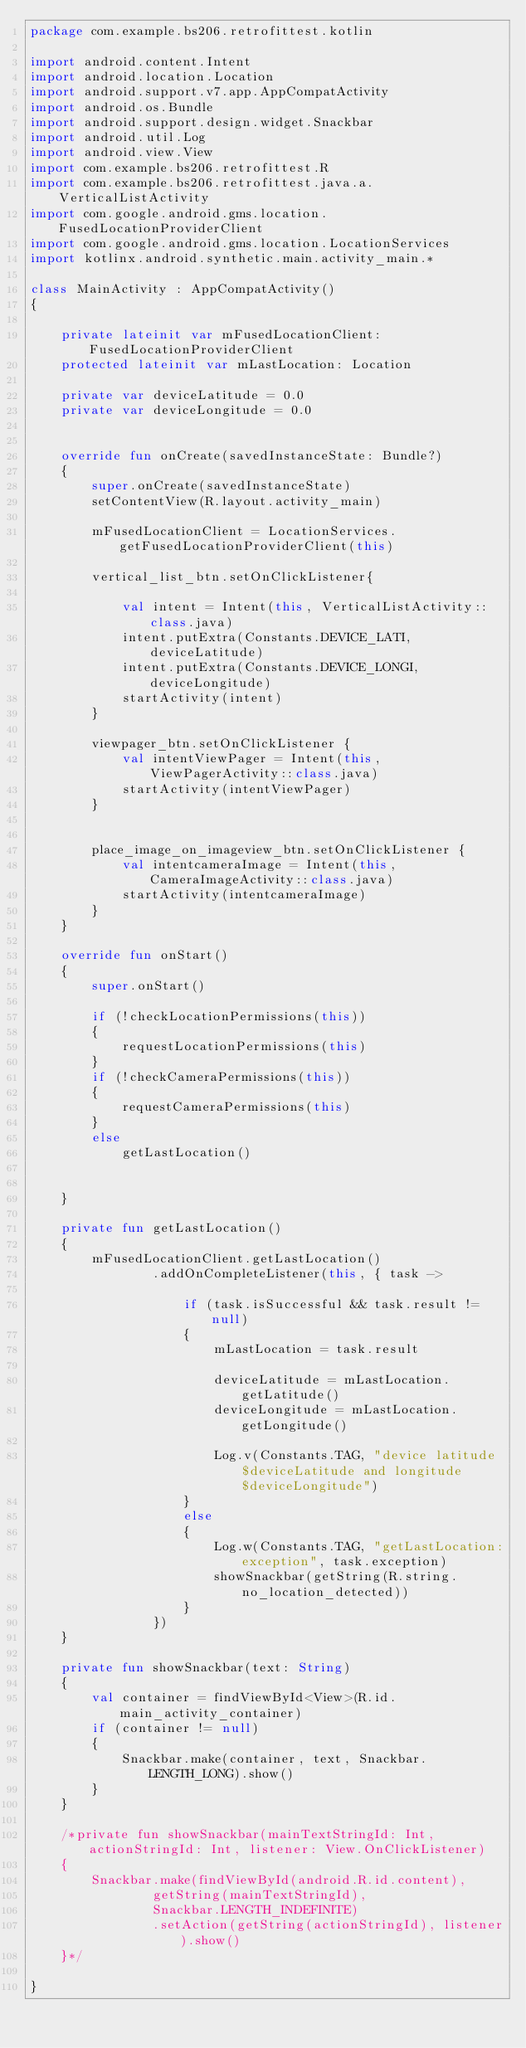Convert code to text. <code><loc_0><loc_0><loc_500><loc_500><_Kotlin_>package com.example.bs206.retrofittest.kotlin

import android.content.Intent
import android.location.Location
import android.support.v7.app.AppCompatActivity
import android.os.Bundle
import android.support.design.widget.Snackbar
import android.util.Log
import android.view.View
import com.example.bs206.retrofittest.R
import com.example.bs206.retrofittest.java.a.VerticalListActivity
import com.google.android.gms.location.FusedLocationProviderClient
import com.google.android.gms.location.LocationServices
import kotlinx.android.synthetic.main.activity_main.*

class MainActivity : AppCompatActivity()
{

    private lateinit var mFusedLocationClient: FusedLocationProviderClient
    protected lateinit var mLastLocation: Location

    private var deviceLatitude = 0.0
    private var deviceLongitude = 0.0


    override fun onCreate(savedInstanceState: Bundle?)
    {
        super.onCreate(savedInstanceState)
        setContentView(R.layout.activity_main)

        mFusedLocationClient = LocationServices.getFusedLocationProviderClient(this)

        vertical_list_btn.setOnClickListener{

            val intent = Intent(this, VerticalListActivity::class.java)
            intent.putExtra(Constants.DEVICE_LATI, deviceLatitude)
            intent.putExtra(Constants.DEVICE_LONGI, deviceLongitude)
            startActivity(intent)
        }

        viewpager_btn.setOnClickListener {
            val intentViewPager = Intent(this, ViewPagerActivity::class.java)
            startActivity(intentViewPager)
        }


        place_image_on_imageview_btn.setOnClickListener {
            val intentcameraImage = Intent(this, CameraImageActivity::class.java)
            startActivity(intentcameraImage)
        }
    }

    override fun onStart()
    {
        super.onStart()

        if (!checkLocationPermissions(this))
        {
            requestLocationPermissions(this)
        }
        if (!checkCameraPermissions(this))
        {
            requestCameraPermissions(this)
        }
        else
            getLastLocation()


    }

    private fun getLastLocation()
    {
        mFusedLocationClient.getLastLocation()
                .addOnCompleteListener(this, { task ->

                    if (task.isSuccessful && task.result != null)
                    {
                        mLastLocation = task.result

                        deviceLatitude = mLastLocation.getLatitude()
                        deviceLongitude = mLastLocation.getLongitude()

                        Log.v(Constants.TAG, "device latitude $deviceLatitude and longitude $deviceLongitude")
                    }
                    else
                    {
                        Log.w(Constants.TAG, "getLastLocation:exception", task.exception)
                        showSnackbar(getString(R.string.no_location_detected))
                    }
                })
    }

    private fun showSnackbar(text: String)
    {
        val container = findViewById<View>(R.id.main_activity_container)
        if (container != null)
        {
            Snackbar.make(container, text, Snackbar.LENGTH_LONG).show()
        }
    }

    /*private fun showSnackbar(mainTextStringId: Int, actionStringId: Int, listener: View.OnClickListener)
    {
        Snackbar.make(findViewById(android.R.id.content),
                getString(mainTextStringId),
                Snackbar.LENGTH_INDEFINITE)
                .setAction(getString(actionStringId), listener).show()
    }*/

}
</code> 